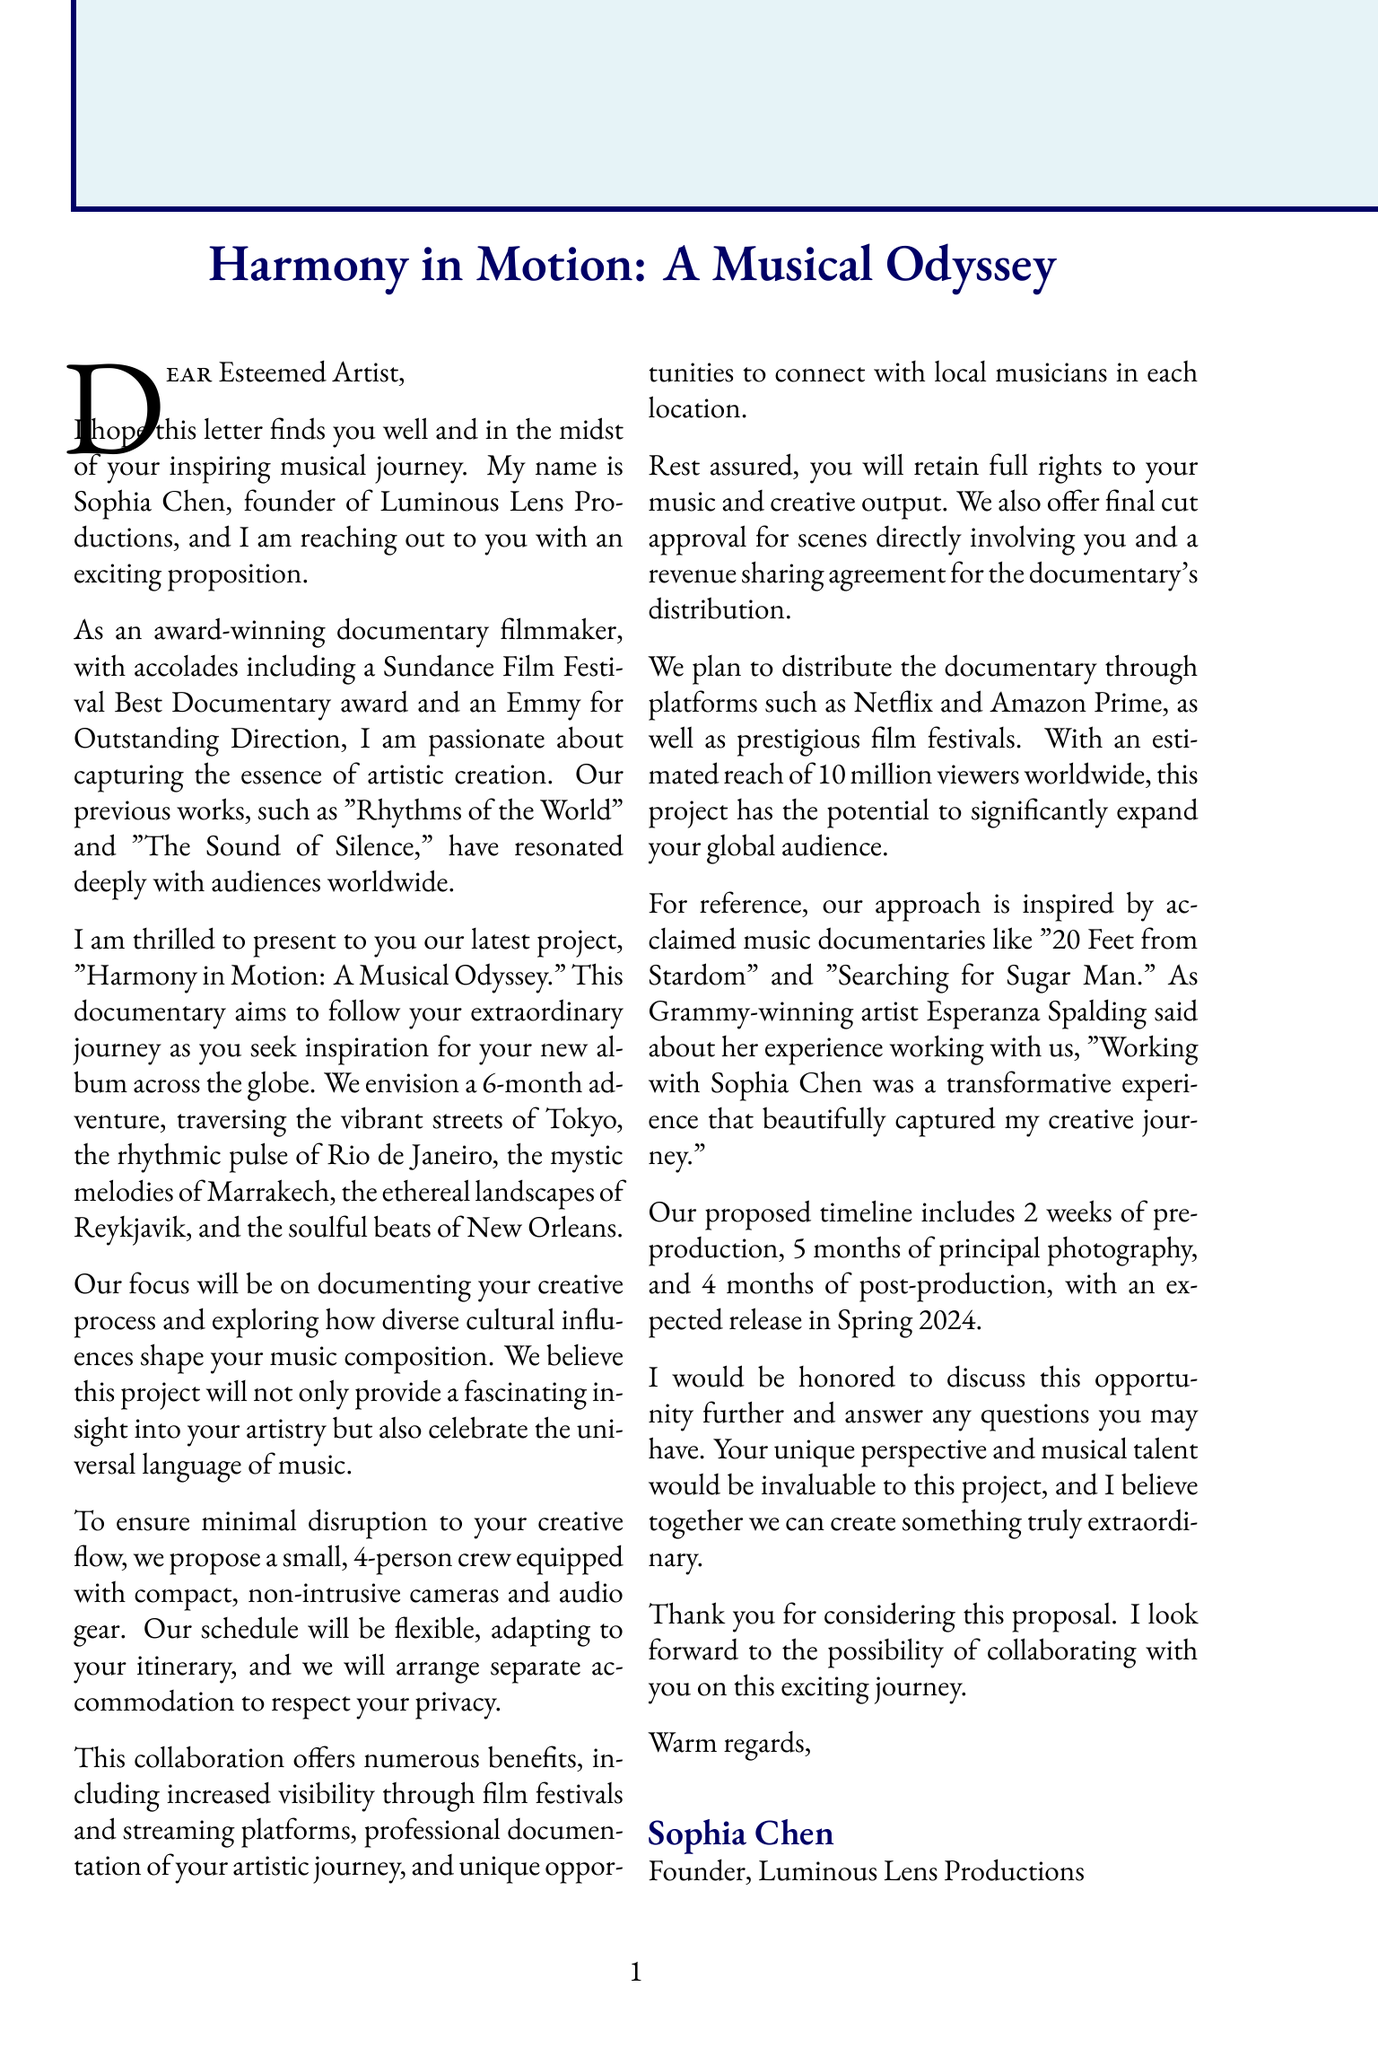What is the name of the filmmaker? The document states the filmmaker's name is Sophia Chen.
Answer: Sophia Chen What is the duration of the project? The project details specify that the duration is 6 months.
Answer: 6 months What locations will the documentary cover? The letter lists the locations as Tokyo, Rio de Janeiro, Marrakech, Reykjavik, and New Orleans.
Answer: Tokyo, Rio de Janeiro, Marrakech, Reykjavik, New Orleans How many crew members will be involved in the filming? The document mentions a 4-person team for the project.
Answer: 4-person team What is the expected release date for the documentary? The proposed timeline indicates an expected release in Spring 2024.
Answer: Spring 2024 What rights does the artist retain? The document specifies that the artist retains full rights to their music and creative output.
Answer: Full rights to their music and creative output What is one of the benefits for the artist mentioned in the letter? One of the benefits is increased visibility through film festivals and streaming platforms.
Answer: Increased visibility through film festivals and streaming platforms Who is quoted as giving a testimonial about the filmmaker? The letter mentions Esperanza Spalding as providing a testimonial.
Answer: Esperanza Spalding What is the primary focus of the documentary? The focus of the documentary is on the creative process and cultural influences on music composition.
Answer: The creative process and cultural influences on music composition 